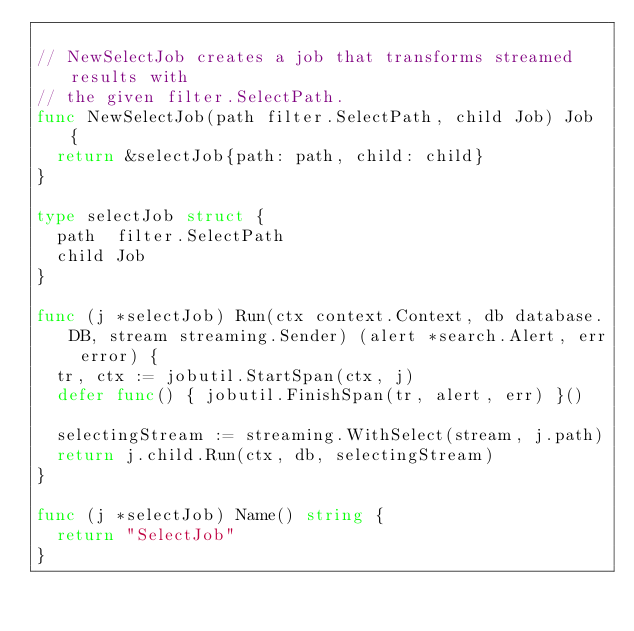Convert code to text. <code><loc_0><loc_0><loc_500><loc_500><_Go_>
// NewSelectJob creates a job that transforms streamed results with
// the given filter.SelectPath.
func NewSelectJob(path filter.SelectPath, child Job) Job {
	return &selectJob{path: path, child: child}
}

type selectJob struct {
	path  filter.SelectPath
	child Job
}

func (j *selectJob) Run(ctx context.Context, db database.DB, stream streaming.Sender) (alert *search.Alert, err error) {
	tr, ctx := jobutil.StartSpan(ctx, j)
	defer func() { jobutil.FinishSpan(tr, alert, err) }()

	selectingStream := streaming.WithSelect(stream, j.path)
	return j.child.Run(ctx, db, selectingStream)
}

func (j *selectJob) Name() string {
	return "SelectJob"
}
</code> 